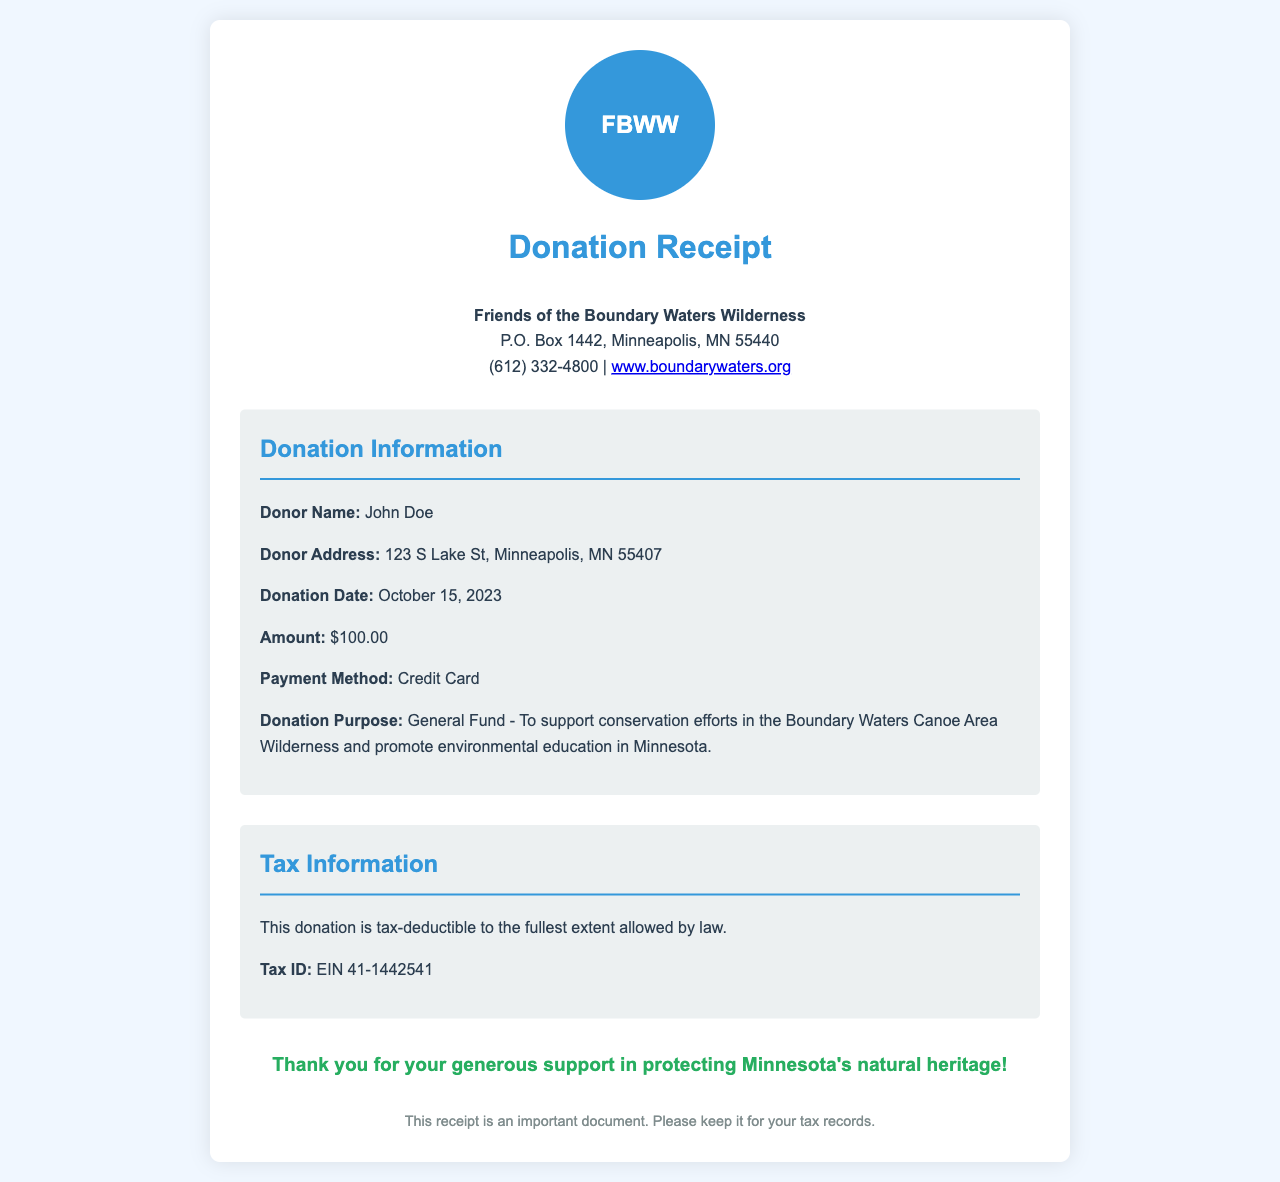What is the name of the organization? The organization name is presented prominently at the top of the document.
Answer: Friends of the Boundary Waters Wilderness What was the donation amount? The donation amount is listed in the donation details section.
Answer: $100.00 Who is the donor? The donor's name is specified in the donation details.
Answer: John Doe What was the donation date? The date of the donation is mentioned in the donation information section.
Answer: October 15, 2023 What is the purpose of the donation? The donation purpose is described clearly in the donation details.
Answer: General Fund - To support conservation efforts in the Boundary Waters Canoe Area Wilderness and promote environmental education in Minnesota What payment method was used? The payment method is indicated in the donation details of the document.
Answer: Credit Card Is this donation tax-deductible? The tax information section confirms the status of the donation regarding tax-deductibility.
Answer: Yes What is the contact number for the organization? The contact information for the organization is listed at the top of the document.
Answer: (612) 332-4800 What is the tax ID number for this organization? The tax ID number is provided in the tax information section.
Answer: EIN 41-1442541 